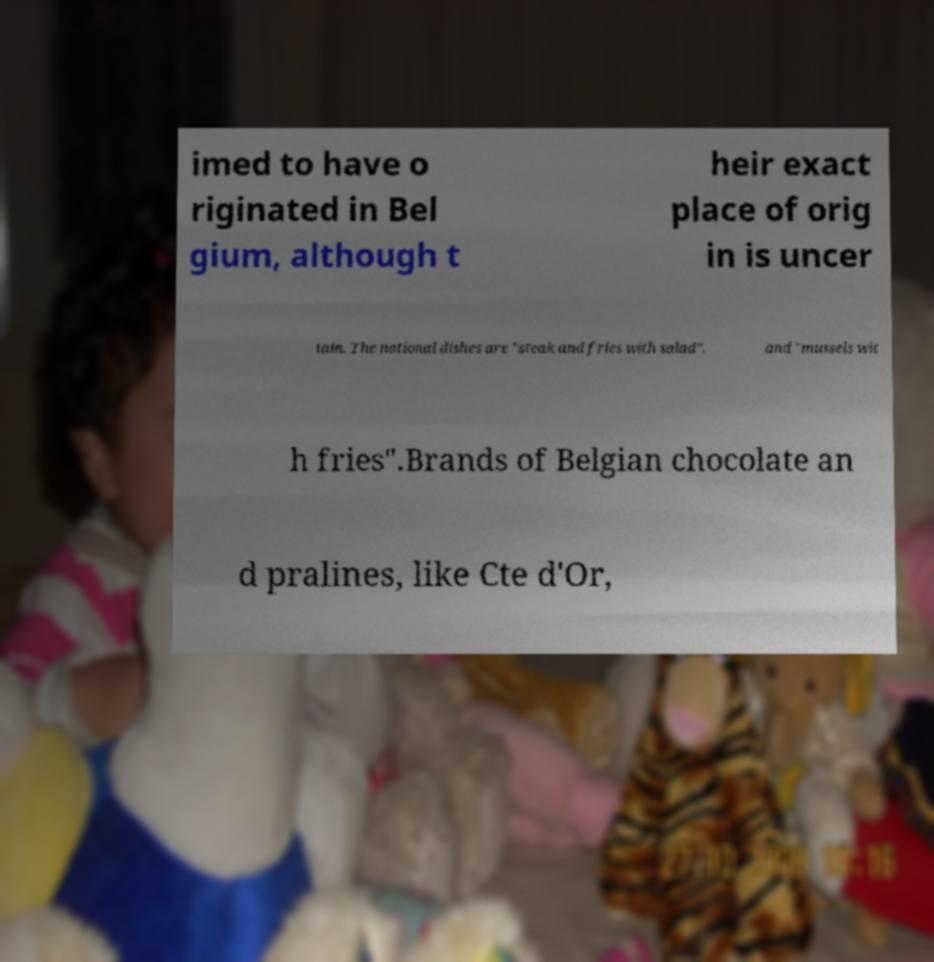Can you read and provide the text displayed in the image?This photo seems to have some interesting text. Can you extract and type it out for me? imed to have o riginated in Bel gium, although t heir exact place of orig in is uncer tain. The national dishes are "steak and fries with salad", and "mussels wit h fries".Brands of Belgian chocolate an d pralines, like Cte d'Or, 